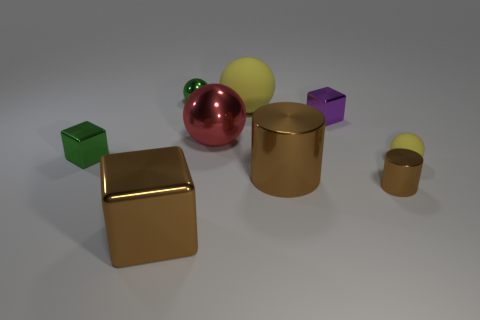What can you infer about the surface upon which these objects are placed? The surface appears smooth and matte, with a faint reflection, suggesting it might be a floor with a satin finish. 